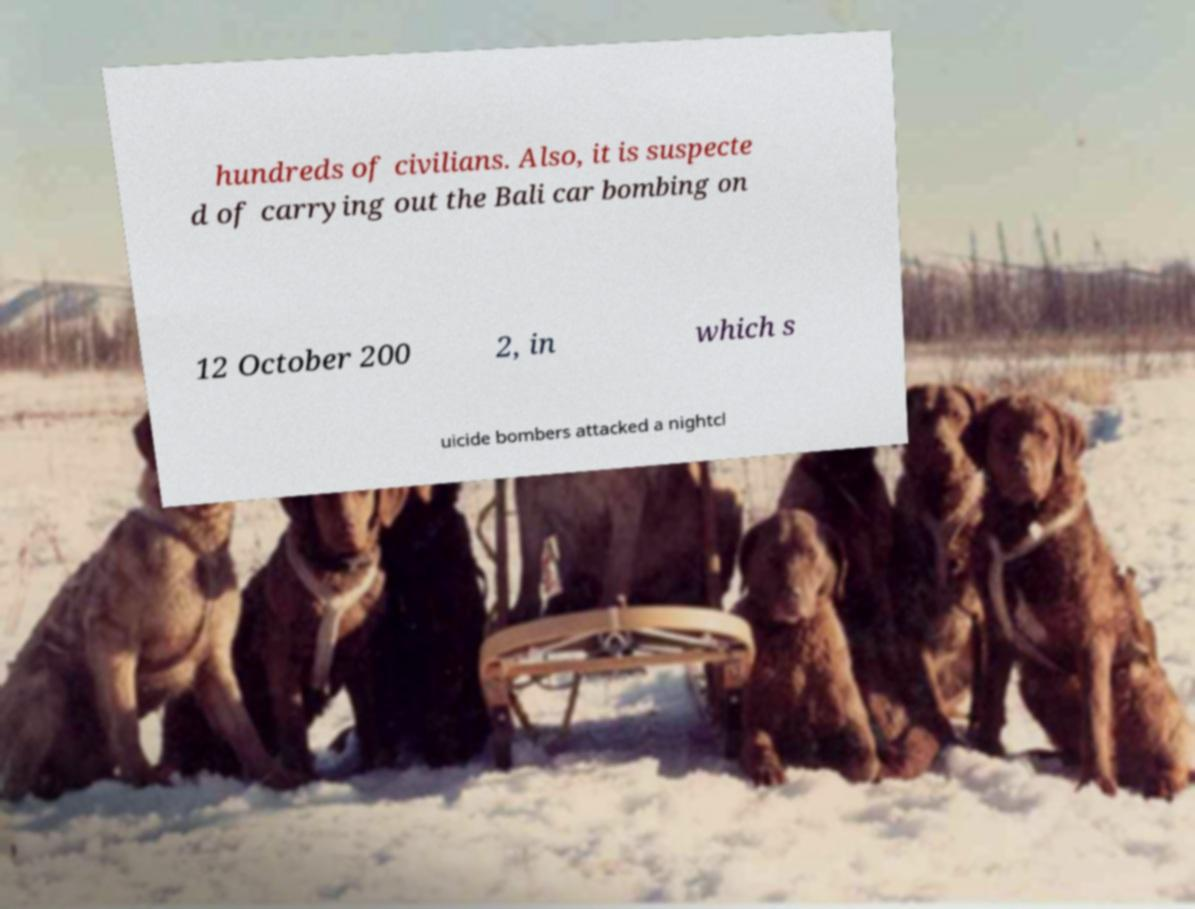Please read and relay the text visible in this image. What does it say? hundreds of civilians. Also, it is suspecte d of carrying out the Bali car bombing on 12 October 200 2, in which s uicide bombers attacked a nightcl 